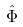Convert formula to latex. <formula><loc_0><loc_0><loc_500><loc_500>\hat { \Phi }</formula> 